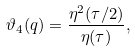Convert formula to latex. <formula><loc_0><loc_0><loc_500><loc_500>\vartheta _ { 4 } ( q ) = \frac { \eta ^ { 2 } ( \tau / 2 ) } { \eta ( \tau ) } ,</formula> 